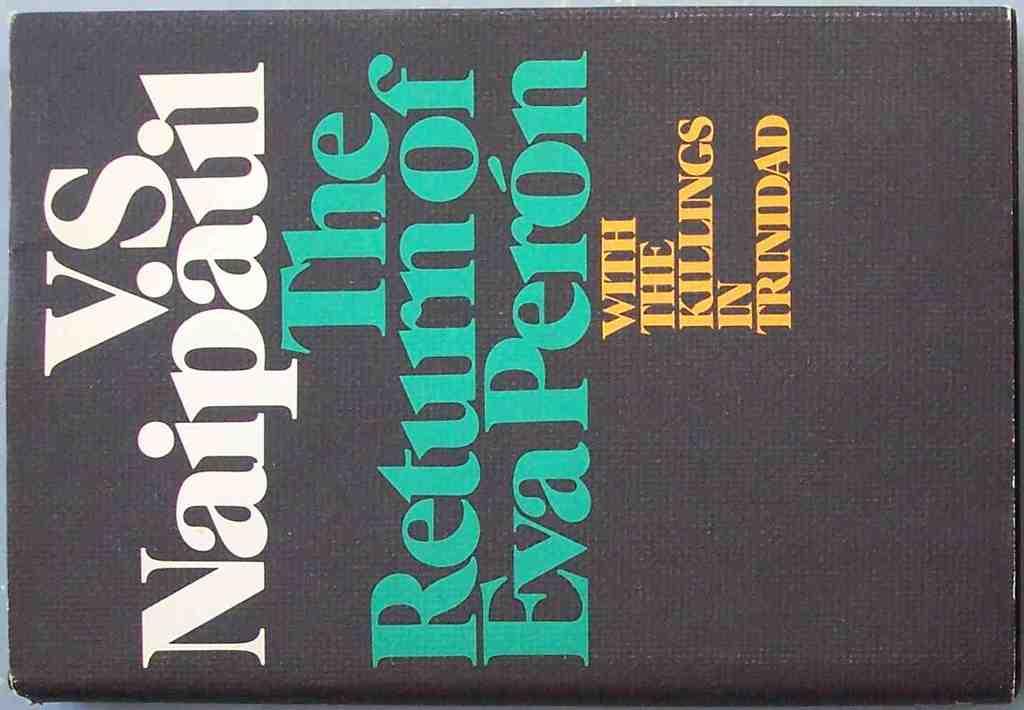In what country did the killings happen?
Offer a very short reply. Trinidad. What is the title of the book?
Offer a very short reply. The return of eva peron. 